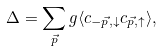<formula> <loc_0><loc_0><loc_500><loc_500>\Delta = \sum _ { \vec { p } } g \langle c _ { - \vec { p } , \downarrow } c _ { \vec { p } , \uparrow } \rangle ,</formula> 